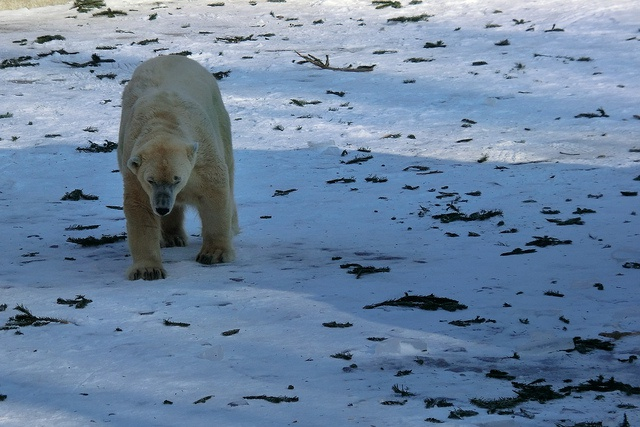Describe the objects in this image and their specific colors. I can see a bear in tan, gray, and black tones in this image. 